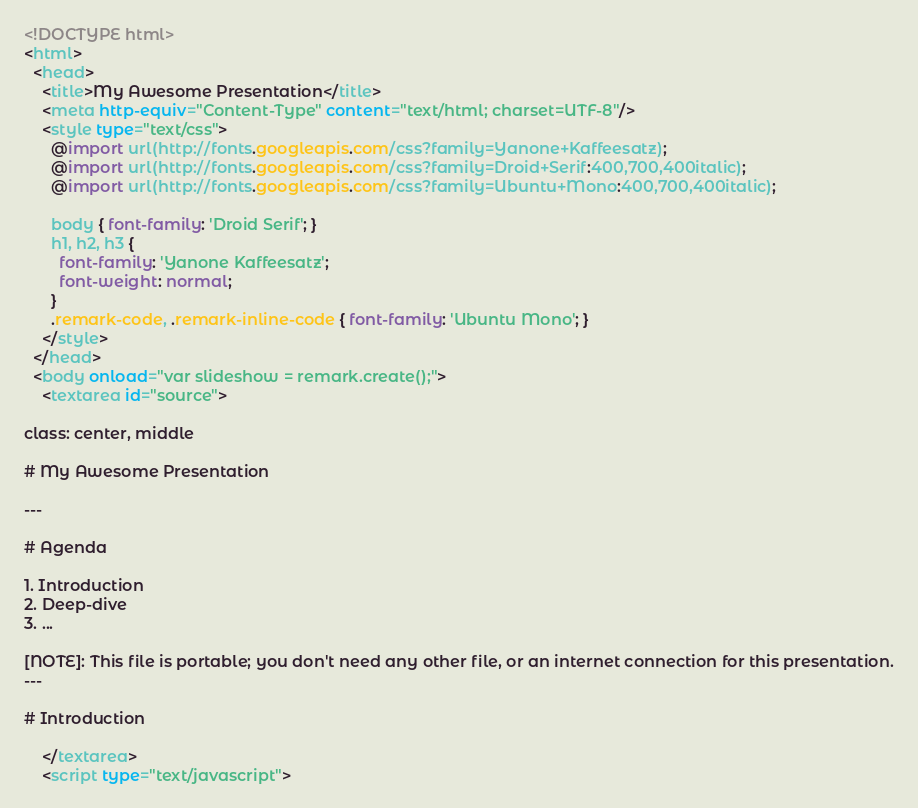Convert code to text. <code><loc_0><loc_0><loc_500><loc_500><_HTML_><!DOCTYPE html>
<html>
  <head>
    <title>My Awesome Presentation</title>
    <meta http-equiv="Content-Type" content="text/html; charset=UTF-8"/>
    <style type="text/css">
      @import url(http://fonts.googleapis.com/css?family=Yanone+Kaffeesatz);
      @import url(http://fonts.googleapis.com/css?family=Droid+Serif:400,700,400italic);
      @import url(http://fonts.googleapis.com/css?family=Ubuntu+Mono:400,700,400italic);

      body { font-family: 'Droid Serif'; }
      h1, h2, h3 {
        font-family: 'Yanone Kaffeesatz';
        font-weight: normal;
      }
      .remark-code, .remark-inline-code { font-family: 'Ubuntu Mono'; }
    </style>
  </head>
  <body onload="var slideshow = remark.create();">
    <textarea id="source">

class: center, middle

# My Awesome Presentation

---

# Agenda

1. Introduction
2. Deep-dive
3. ...

[NOTE]: This file is portable; you don't need any other file, or an internet connection for this presentation.
---

# Introduction

    </textarea>
    <script type="text/javascript"></code> 